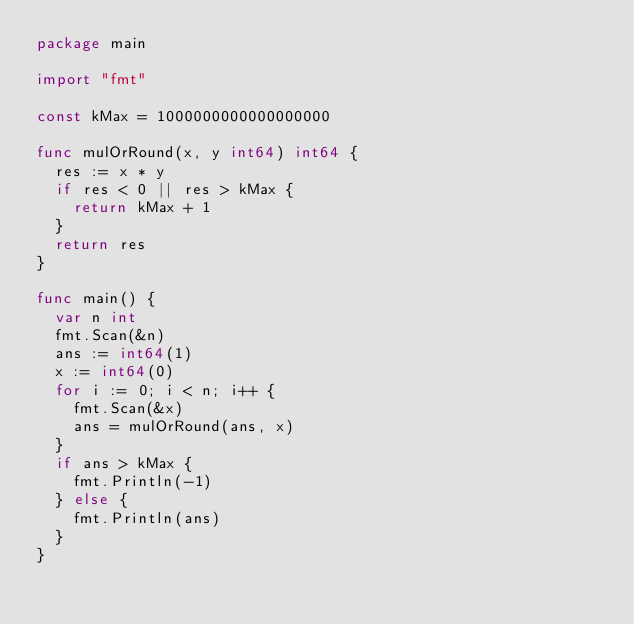<code> <loc_0><loc_0><loc_500><loc_500><_Go_>package main

import "fmt"

const kMax = 1000000000000000000

func mulOrRound(x, y int64) int64 {
	res := x * y
	if res < 0 || res > kMax {
		return kMax + 1
	}
	return res
}

func main() {
	var n int
	fmt.Scan(&n)
	ans := int64(1)
	x := int64(0)
	for i := 0; i < n; i++ {
		fmt.Scan(&x)
		ans = mulOrRound(ans, x)
	}
	if ans > kMax {
		fmt.Println(-1)
	} else {
		fmt.Println(ans)
	}
}
</code> 